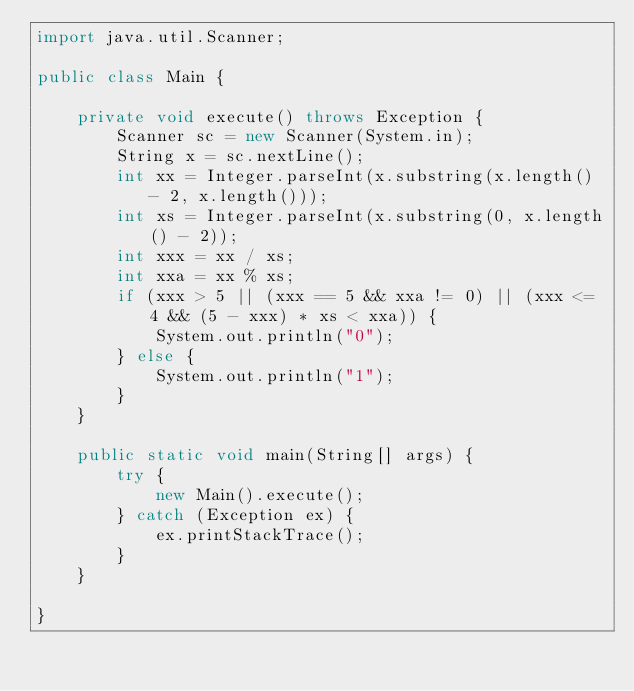<code> <loc_0><loc_0><loc_500><loc_500><_Java_>import java.util.Scanner;

public class Main {

    private void execute() throws Exception {
        Scanner sc = new Scanner(System.in);
        String x = sc.nextLine();
        int xx = Integer.parseInt(x.substring(x.length() - 2, x.length()));
        int xs = Integer.parseInt(x.substring(0, x.length() - 2));
        int xxx = xx / xs;
        int xxa = xx % xs;
        if (xxx > 5 || (xxx == 5 && xxa != 0) || (xxx <= 4 && (5 - xxx) * xs < xxa)) {
            System.out.println("0");
        } else {
            System.out.println("1");
        }
    }

    public static void main(String[] args) {
        try {
            new Main().execute();
        } catch (Exception ex) {
            ex.printStackTrace();
        }
    }

}</code> 